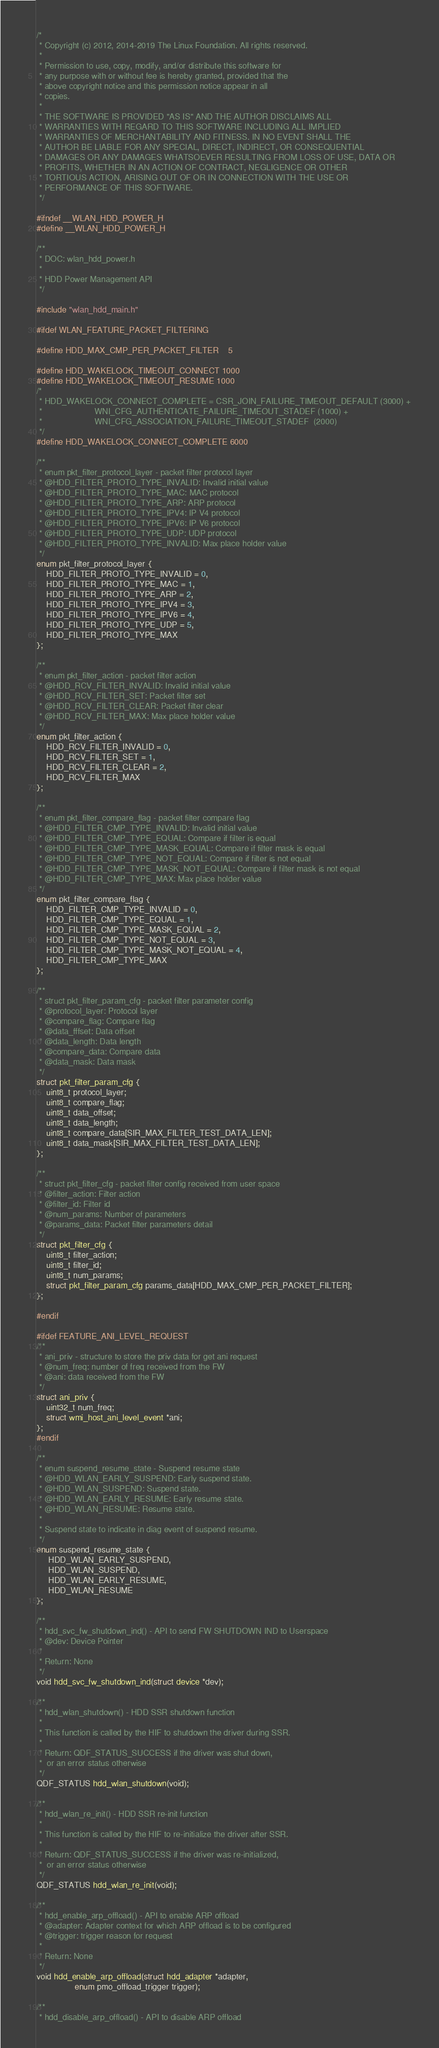<code> <loc_0><loc_0><loc_500><loc_500><_C_>/*
 * Copyright (c) 2012, 2014-2019 The Linux Foundation. All rights reserved.
 *
 * Permission to use, copy, modify, and/or distribute this software for
 * any purpose with or without fee is hereby granted, provided that the
 * above copyright notice and this permission notice appear in all
 * copies.
 *
 * THE SOFTWARE IS PROVIDED "AS IS" AND THE AUTHOR DISCLAIMS ALL
 * WARRANTIES WITH REGARD TO THIS SOFTWARE INCLUDING ALL IMPLIED
 * WARRANTIES OF MERCHANTABILITY AND FITNESS. IN NO EVENT SHALL THE
 * AUTHOR BE LIABLE FOR ANY SPECIAL, DIRECT, INDIRECT, OR CONSEQUENTIAL
 * DAMAGES OR ANY DAMAGES WHATSOEVER RESULTING FROM LOSS OF USE, DATA OR
 * PROFITS, WHETHER IN AN ACTION OF CONTRACT, NEGLIGENCE OR OTHER
 * TORTIOUS ACTION, ARISING OUT OF OR IN CONNECTION WITH THE USE OR
 * PERFORMANCE OF THIS SOFTWARE.
 */

#ifndef __WLAN_HDD_POWER_H
#define __WLAN_HDD_POWER_H

/**
 * DOC: wlan_hdd_power.h
 *
 * HDD Power Management API
 */

#include "wlan_hdd_main.h"

#ifdef WLAN_FEATURE_PACKET_FILTERING

#define HDD_MAX_CMP_PER_PACKET_FILTER	5

#define HDD_WAKELOCK_TIMEOUT_CONNECT 1000
#define HDD_WAKELOCK_TIMEOUT_RESUME 1000
/*
 * HDD_WAKELOCK_CONNECT_COMPLETE = CSR_JOIN_FAILURE_TIMEOUT_DEFAULT (3000) +
 *                      WNI_CFG_AUTHENTICATE_FAILURE_TIMEOUT_STADEF (1000) +
 *                      WNI_CFG_ASSOCIATION_FAILURE_TIMEOUT_STADEF  (2000)
 */
#define HDD_WAKELOCK_CONNECT_COMPLETE 6000

/**
 * enum pkt_filter_protocol_layer - packet filter protocol layer
 * @HDD_FILTER_PROTO_TYPE_INVALID: Invalid initial value
 * @HDD_FILTER_PROTO_TYPE_MAC: MAC protocol
 * @HDD_FILTER_PROTO_TYPE_ARP: ARP protocol
 * @HDD_FILTER_PROTO_TYPE_IPV4: IP V4 protocol
 * @HDD_FILTER_PROTO_TYPE_IPV6: IP V6 protocol
 * @HDD_FILTER_PROTO_TYPE_UDP: UDP protocol
 * @HDD_FILTER_PROTO_TYPE_INVALID: Max place holder value
 */
enum pkt_filter_protocol_layer {
	HDD_FILTER_PROTO_TYPE_INVALID = 0,
	HDD_FILTER_PROTO_TYPE_MAC = 1,
	HDD_FILTER_PROTO_TYPE_ARP = 2,
	HDD_FILTER_PROTO_TYPE_IPV4 = 3,
	HDD_FILTER_PROTO_TYPE_IPV6 = 4,
	HDD_FILTER_PROTO_TYPE_UDP = 5,
	HDD_FILTER_PROTO_TYPE_MAX
};

/**
 * enum pkt_filter_action - packet filter action
 * @HDD_RCV_FILTER_INVALID: Invalid initial value
 * @HDD_RCV_FILTER_SET: Packet filter set
 * @HDD_RCV_FILTER_CLEAR: Packet filter clear
 * @HDD_RCV_FILTER_MAX: Max place holder value
 */
enum pkt_filter_action {
	HDD_RCV_FILTER_INVALID = 0,
	HDD_RCV_FILTER_SET = 1,
	HDD_RCV_FILTER_CLEAR = 2,
	HDD_RCV_FILTER_MAX
};

/**
 * enum pkt_filter_compare_flag - packet filter compare flag
 * @HDD_FILTER_CMP_TYPE_INVALID: Invalid initial value
 * @HDD_FILTER_CMP_TYPE_EQUAL: Compare if filter is equal
 * @HDD_FILTER_CMP_TYPE_MASK_EQUAL: Compare if filter mask is equal
 * @HDD_FILTER_CMP_TYPE_NOT_EQUAL: Compare if filter is not equal
 * @HDD_FILTER_CMP_TYPE_MASK_NOT_EQUAL: Compare if filter mask is not equal
 * @HDD_FILTER_CMP_TYPE_MAX: Max place holder value
 */
enum pkt_filter_compare_flag {
	HDD_FILTER_CMP_TYPE_INVALID = 0,
	HDD_FILTER_CMP_TYPE_EQUAL = 1,
	HDD_FILTER_CMP_TYPE_MASK_EQUAL = 2,
	HDD_FILTER_CMP_TYPE_NOT_EQUAL = 3,
	HDD_FILTER_CMP_TYPE_MASK_NOT_EQUAL = 4,
	HDD_FILTER_CMP_TYPE_MAX
};

/**
 * struct pkt_filter_param_cfg - packet filter parameter config
 * @protocol_layer: Protocol layer
 * @compare_flag: Compare flag
 * @data_fffset: Data offset
 * @data_length: Data length
 * @compare_data: Compare data
 * @data_mask: Data mask
 */
struct pkt_filter_param_cfg {
	uint8_t protocol_layer;
	uint8_t compare_flag;
	uint8_t data_offset;
	uint8_t data_length;
	uint8_t compare_data[SIR_MAX_FILTER_TEST_DATA_LEN];
	uint8_t data_mask[SIR_MAX_FILTER_TEST_DATA_LEN];
};

/**
 * struct pkt_filter_cfg - packet filter config received from user space
 * @filter_action: Filter action
 * @filter_id: Filter id
 * @num_params: Number of parameters
 * @params_data: Packet filter parameters detail
 */
struct pkt_filter_cfg {
	uint8_t filter_action;
	uint8_t filter_id;
	uint8_t num_params;
	struct pkt_filter_param_cfg params_data[HDD_MAX_CMP_PER_PACKET_FILTER];
};

#endif

#ifdef FEATURE_ANI_LEVEL_REQUEST
/**
 * ani_priv - structure to store the priv data for get ani request
 * @num_freq: number of freq received from the FW
 * @ani: data received from the FW
 */
struct ani_priv {
	uint32_t num_freq;
	struct wmi_host_ani_level_event *ani;
};
#endif

/**
 * enum suspend_resume_state - Suspend resume state
 * @HDD_WLAN_EARLY_SUSPEND: Early suspend state.
 * @HDD_WLAN_SUSPEND: Suspend state.
 * @HDD_WLAN_EARLY_RESUME: Early resume state.
 * @HDD_WLAN_RESUME: Resume state.
 *
 * Suspend state to indicate in diag event of suspend resume.
 */
enum suspend_resume_state {
	 HDD_WLAN_EARLY_SUSPEND,
	 HDD_WLAN_SUSPEND,
	 HDD_WLAN_EARLY_RESUME,
	 HDD_WLAN_RESUME
};

/**
 * hdd_svc_fw_shutdown_ind() - API to send FW SHUTDOWN IND to Userspace
 * @dev: Device Pointer
 *
 * Return: None
 */
void hdd_svc_fw_shutdown_ind(struct device *dev);

/**
 * hdd_wlan_shutdown() - HDD SSR shutdown function
 *
 * This function is called by the HIF to shutdown the driver during SSR.
 *
 * Return: QDF_STATUS_SUCCESS if the driver was shut down,
 *	or an error status otherwise
 */
QDF_STATUS hdd_wlan_shutdown(void);

/**
 * hdd_wlan_re_init() - HDD SSR re-init function
 *
 * This function is called by the HIF to re-initialize the driver after SSR.
 *
 * Return: QDF_STATUS_SUCCESS if the driver was re-initialized,
 *	or an error status otherwise
 */
QDF_STATUS hdd_wlan_re_init(void);

/**
 * hdd_enable_arp_offload() - API to enable ARP offload
 * @adapter: Adapter context for which ARP offload is to be configured
 * @trigger: trigger reason for request
 *
 * Return: None
 */
void hdd_enable_arp_offload(struct hdd_adapter *adapter,
			    enum pmo_offload_trigger trigger);

/**
 * hdd_disable_arp_offload() - API to disable ARP offload</code> 